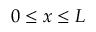<formula> <loc_0><loc_0><loc_500><loc_500>0 \leq x \leq L</formula> 